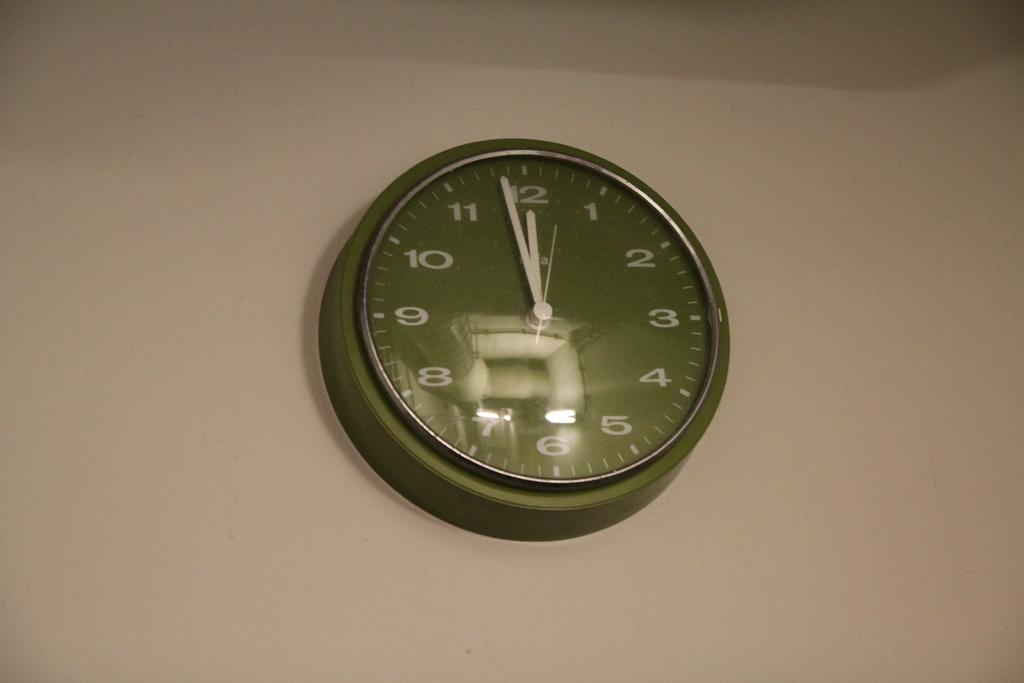What is the main object in the center of the picture? There is a clock in the center of the picture. Where is the clock located? The clock is on the wall. What color is the wall where the clock is mounted? The wall is painted in brown color. Can you see any feathers on the clock in the image? There are no feathers present on the clock in the image. Is this an office setting with the clock in the image? The image does not provide enough information to determine if it is an office setting or not. 